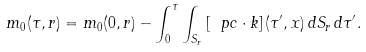Convert formula to latex. <formula><loc_0><loc_0><loc_500><loc_500>m _ { 0 } ( \tau , r ) = m _ { 0 } ( 0 , r ) - \int _ { 0 } ^ { \tau } \int _ { S _ { r } } \left [ \ p c \cdot k \right ] ( \tau ^ { \prime } , x ) \, d S _ { r } \, d \tau ^ { \prime } .</formula> 